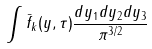Convert formula to latex. <formula><loc_0><loc_0><loc_500><loc_500>\int \bar { f } _ { k } ( y , \tau ) \frac { d y _ { 1 } d y _ { 2 } d y _ { 3 } } { \pi ^ { 3 / 2 } }</formula> 